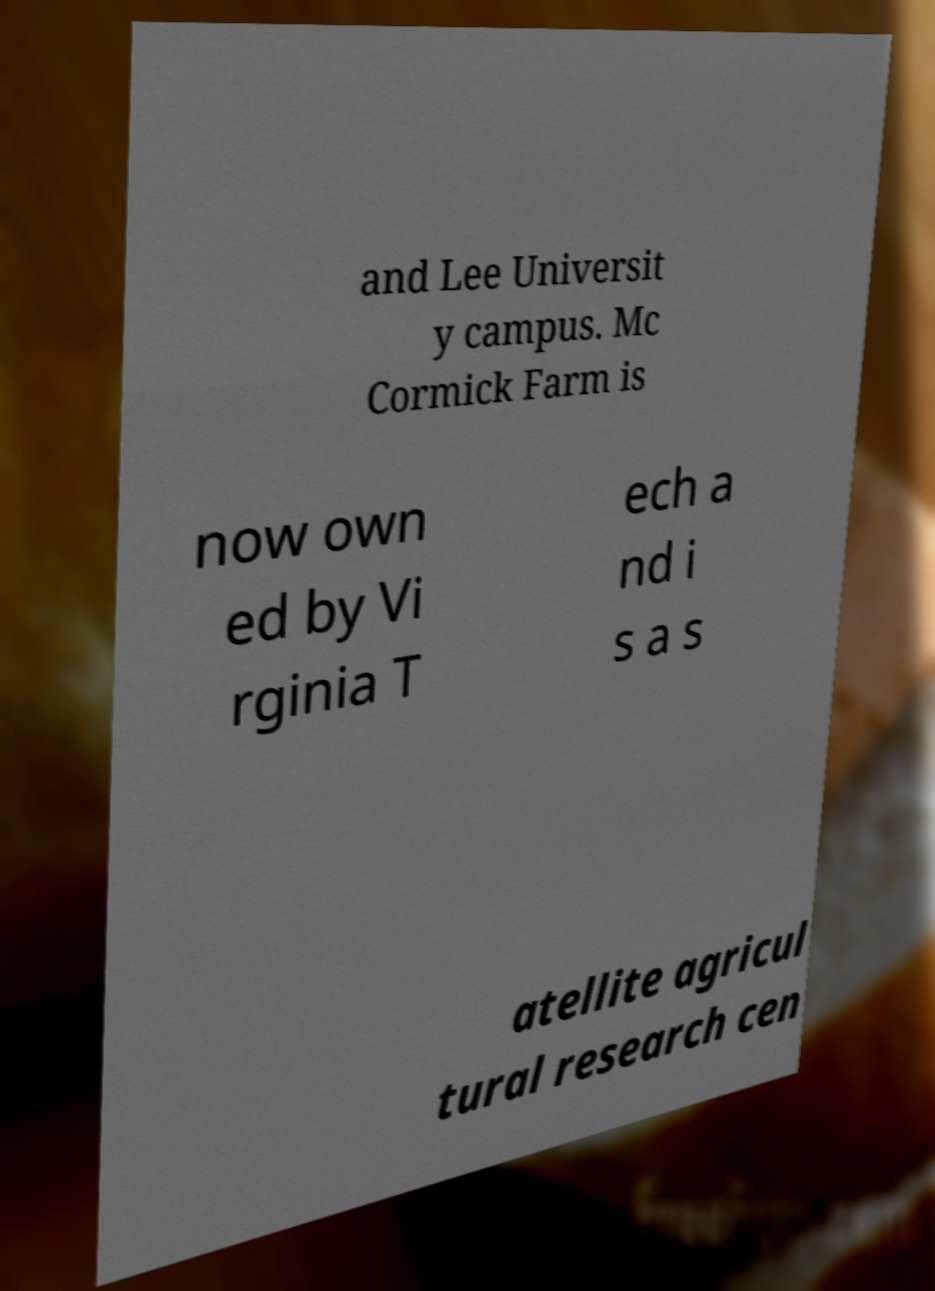Please read and relay the text visible in this image. What does it say? and Lee Universit y campus. Mc Cormick Farm is now own ed by Vi rginia T ech a nd i s a s atellite agricul tural research cen 